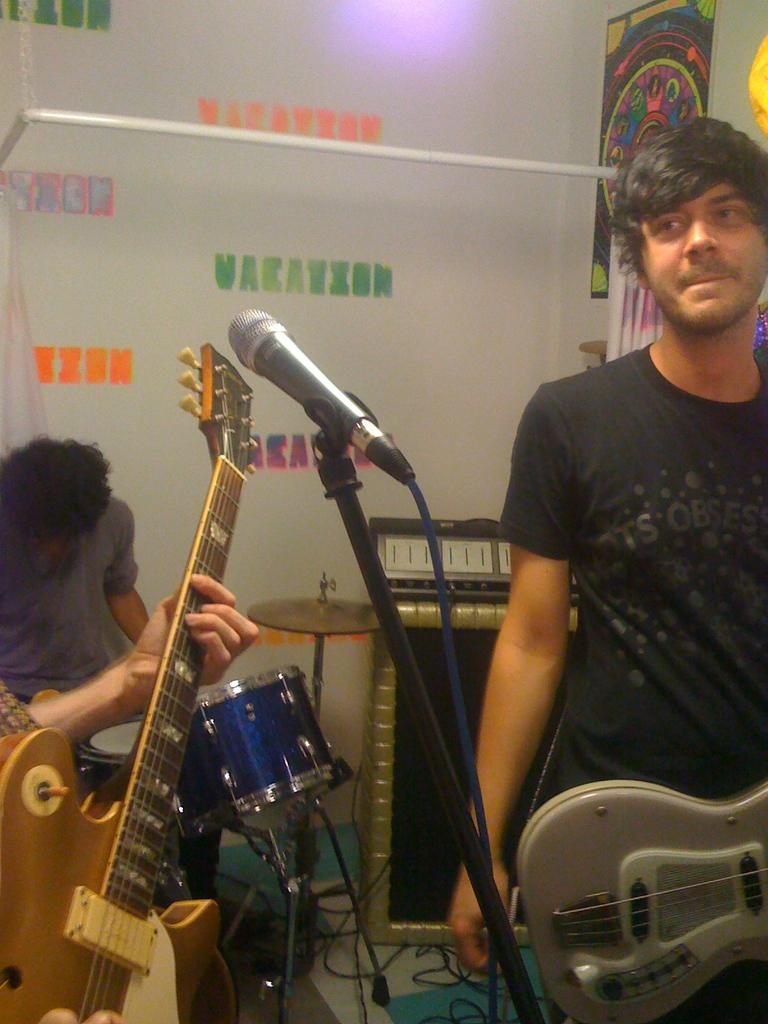Who is the person on the right side of the image? There is a man standing on the right side of the image. What is the man holding in the image? The man is holding a guitar. What can be seen in the image that is typically used for amplifying sound? There is a microphone in the image. What is the person in the background of the image doing? The person in the background is playing a drum. What type of impulse does the queen have in the image? There is no queen present in the image, so it is not possible to determine any impulses she might have. What team is the man playing for in the image? There is no indication of a team or any sports-related activity in the image. 